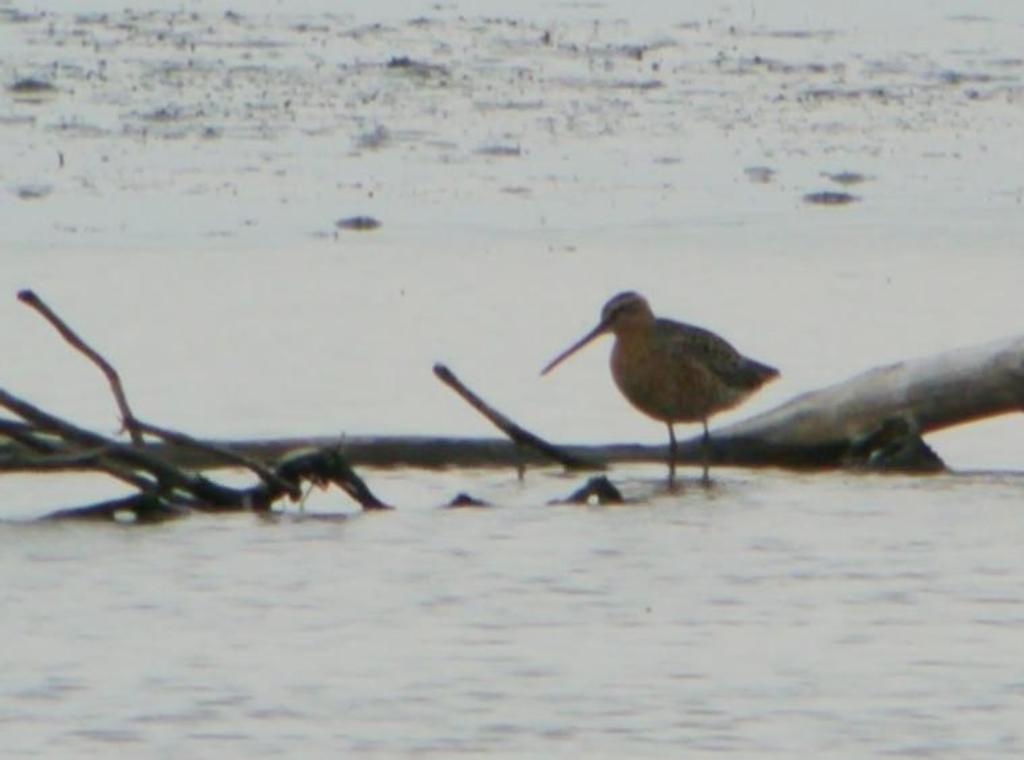In one or two sentences, can you explain what this image depicts? In this image we can see a bird standing on the water. 